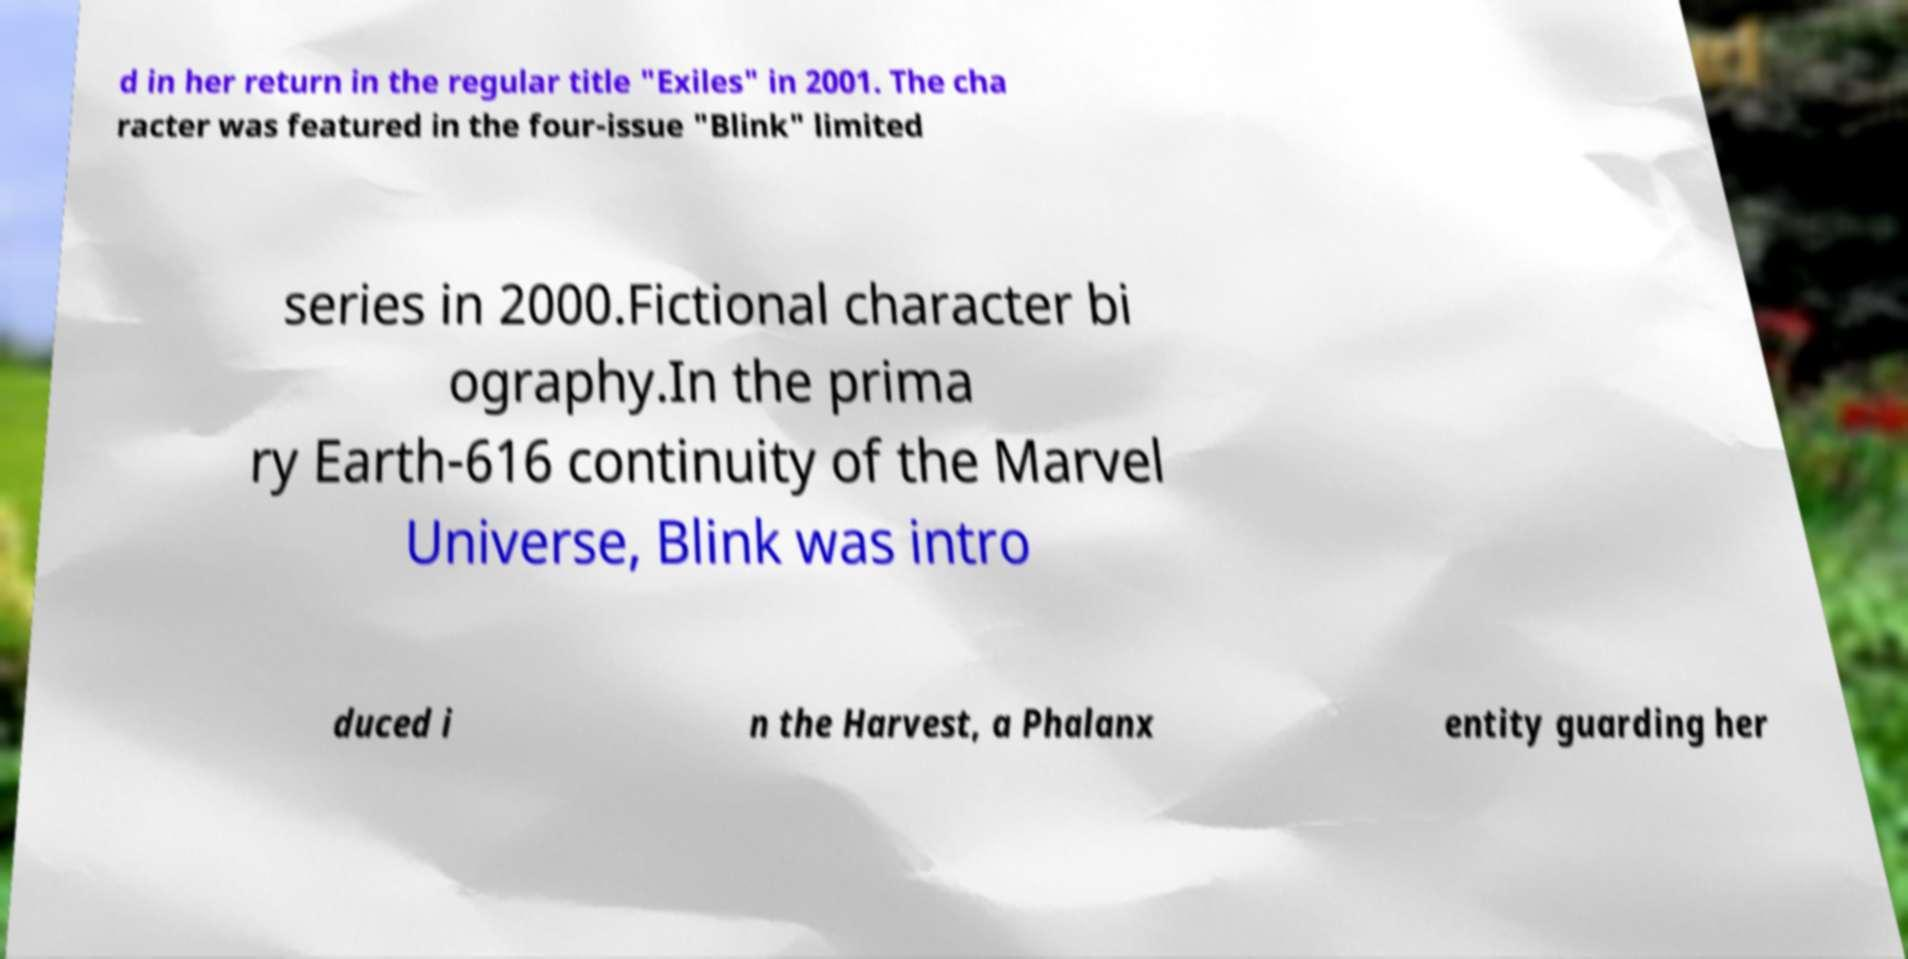Please identify and transcribe the text found in this image. d in her return in the regular title "Exiles" in 2001. The cha racter was featured in the four-issue "Blink" limited series in 2000.Fictional character bi ography.In the prima ry Earth-616 continuity of the Marvel Universe, Blink was intro duced i n the Harvest, a Phalanx entity guarding her 